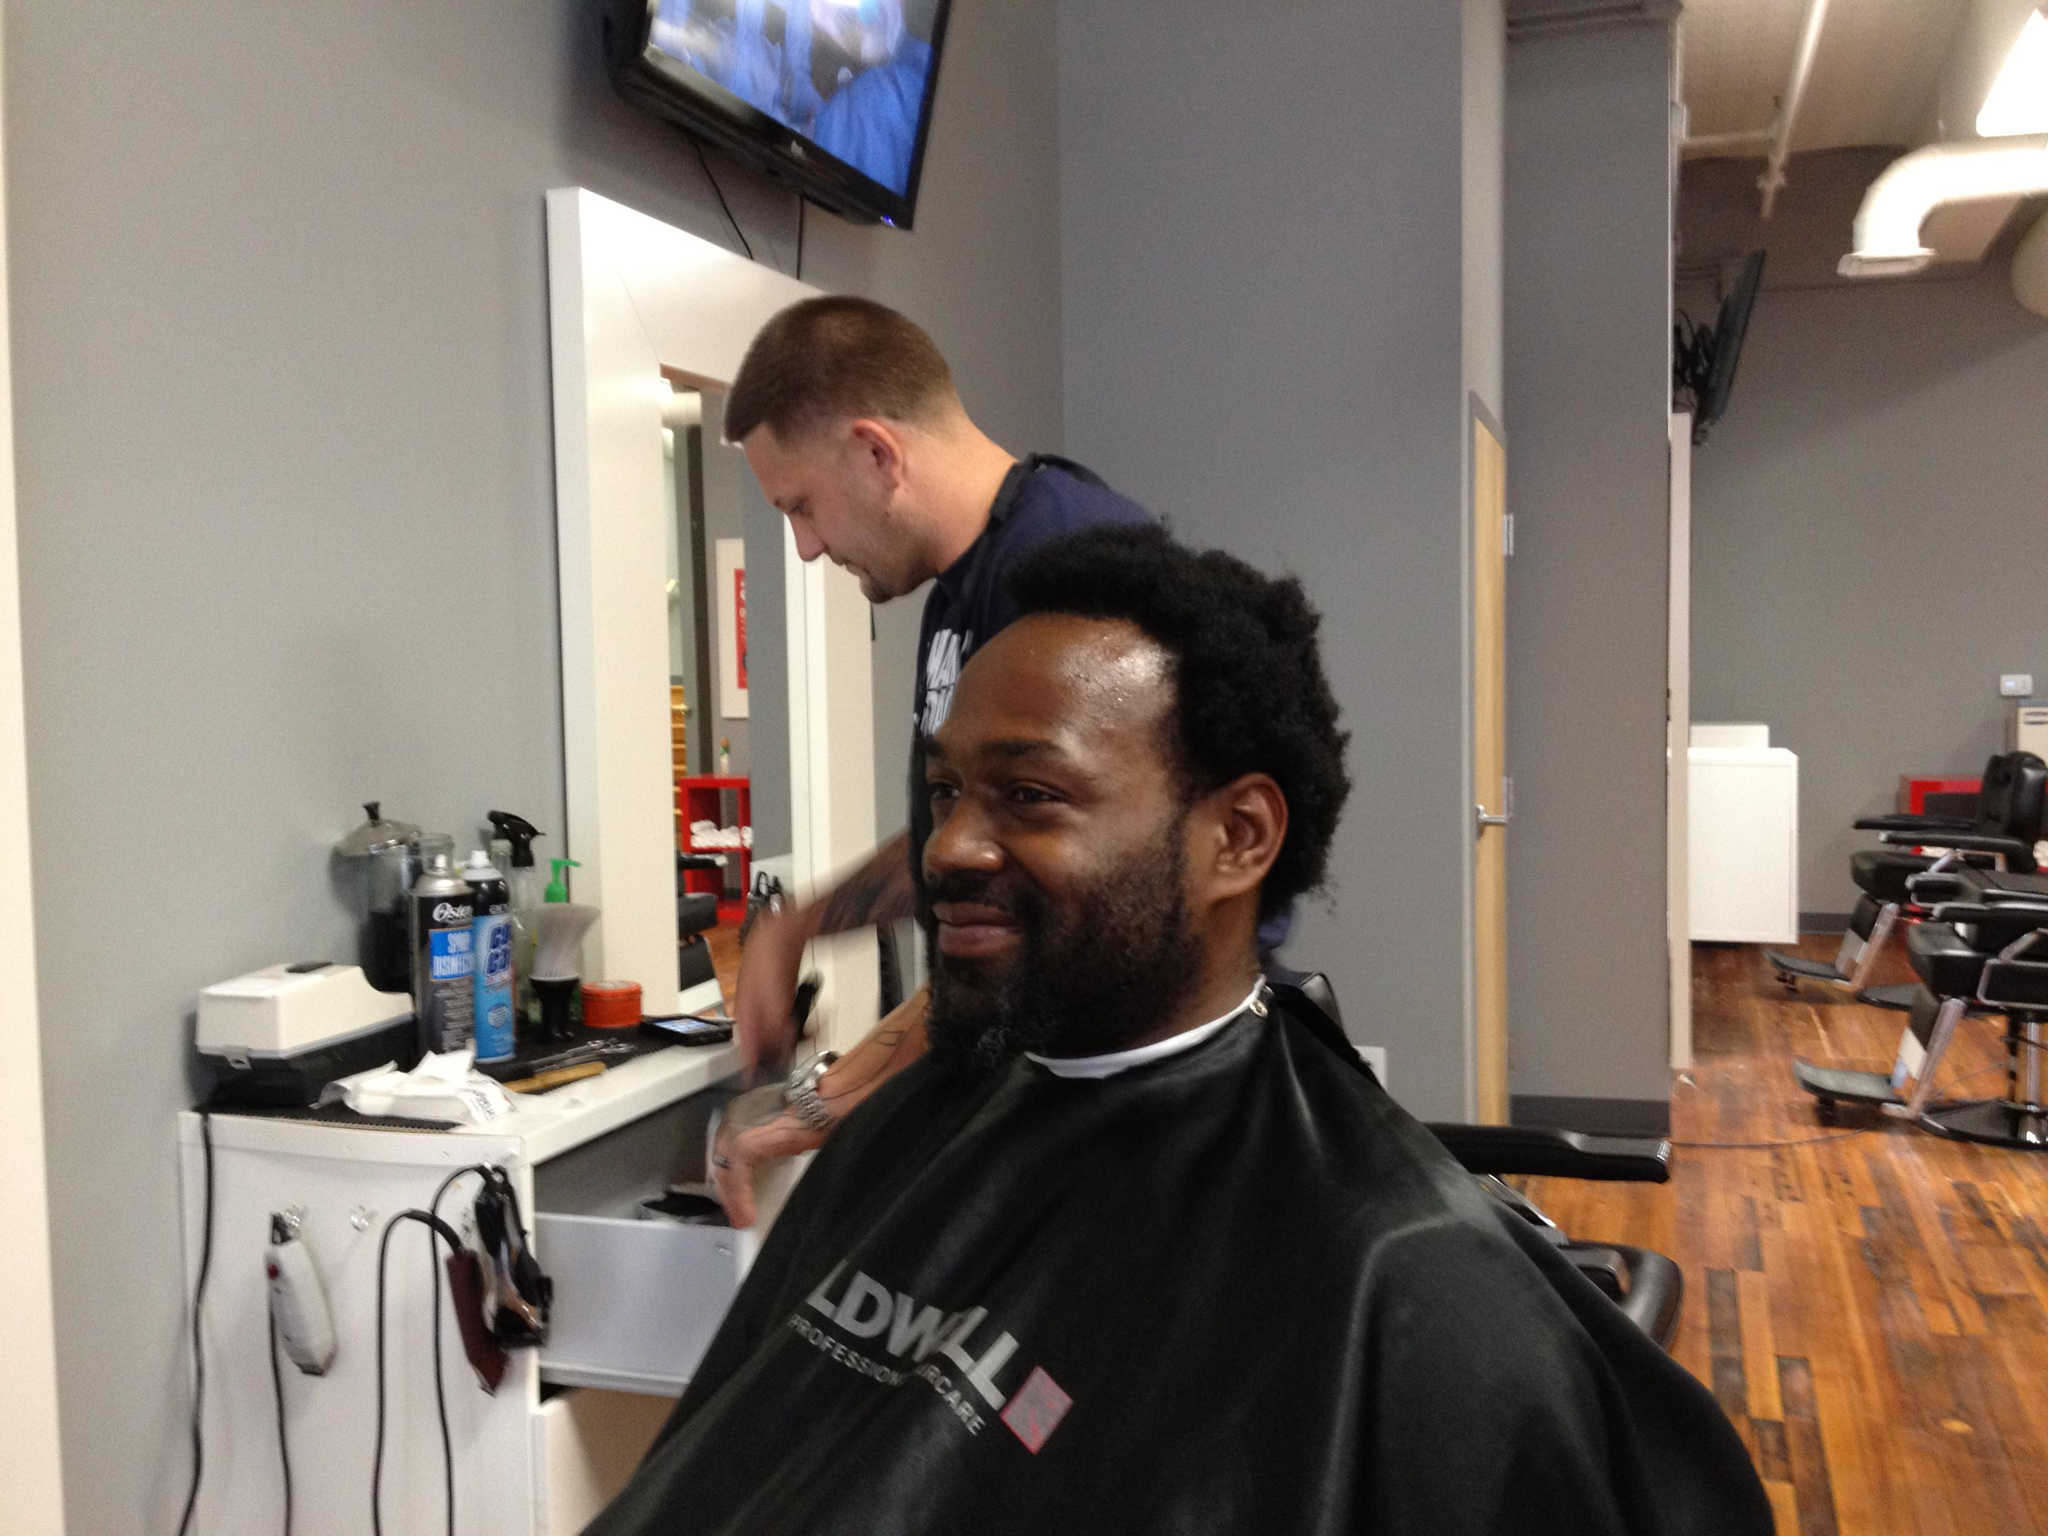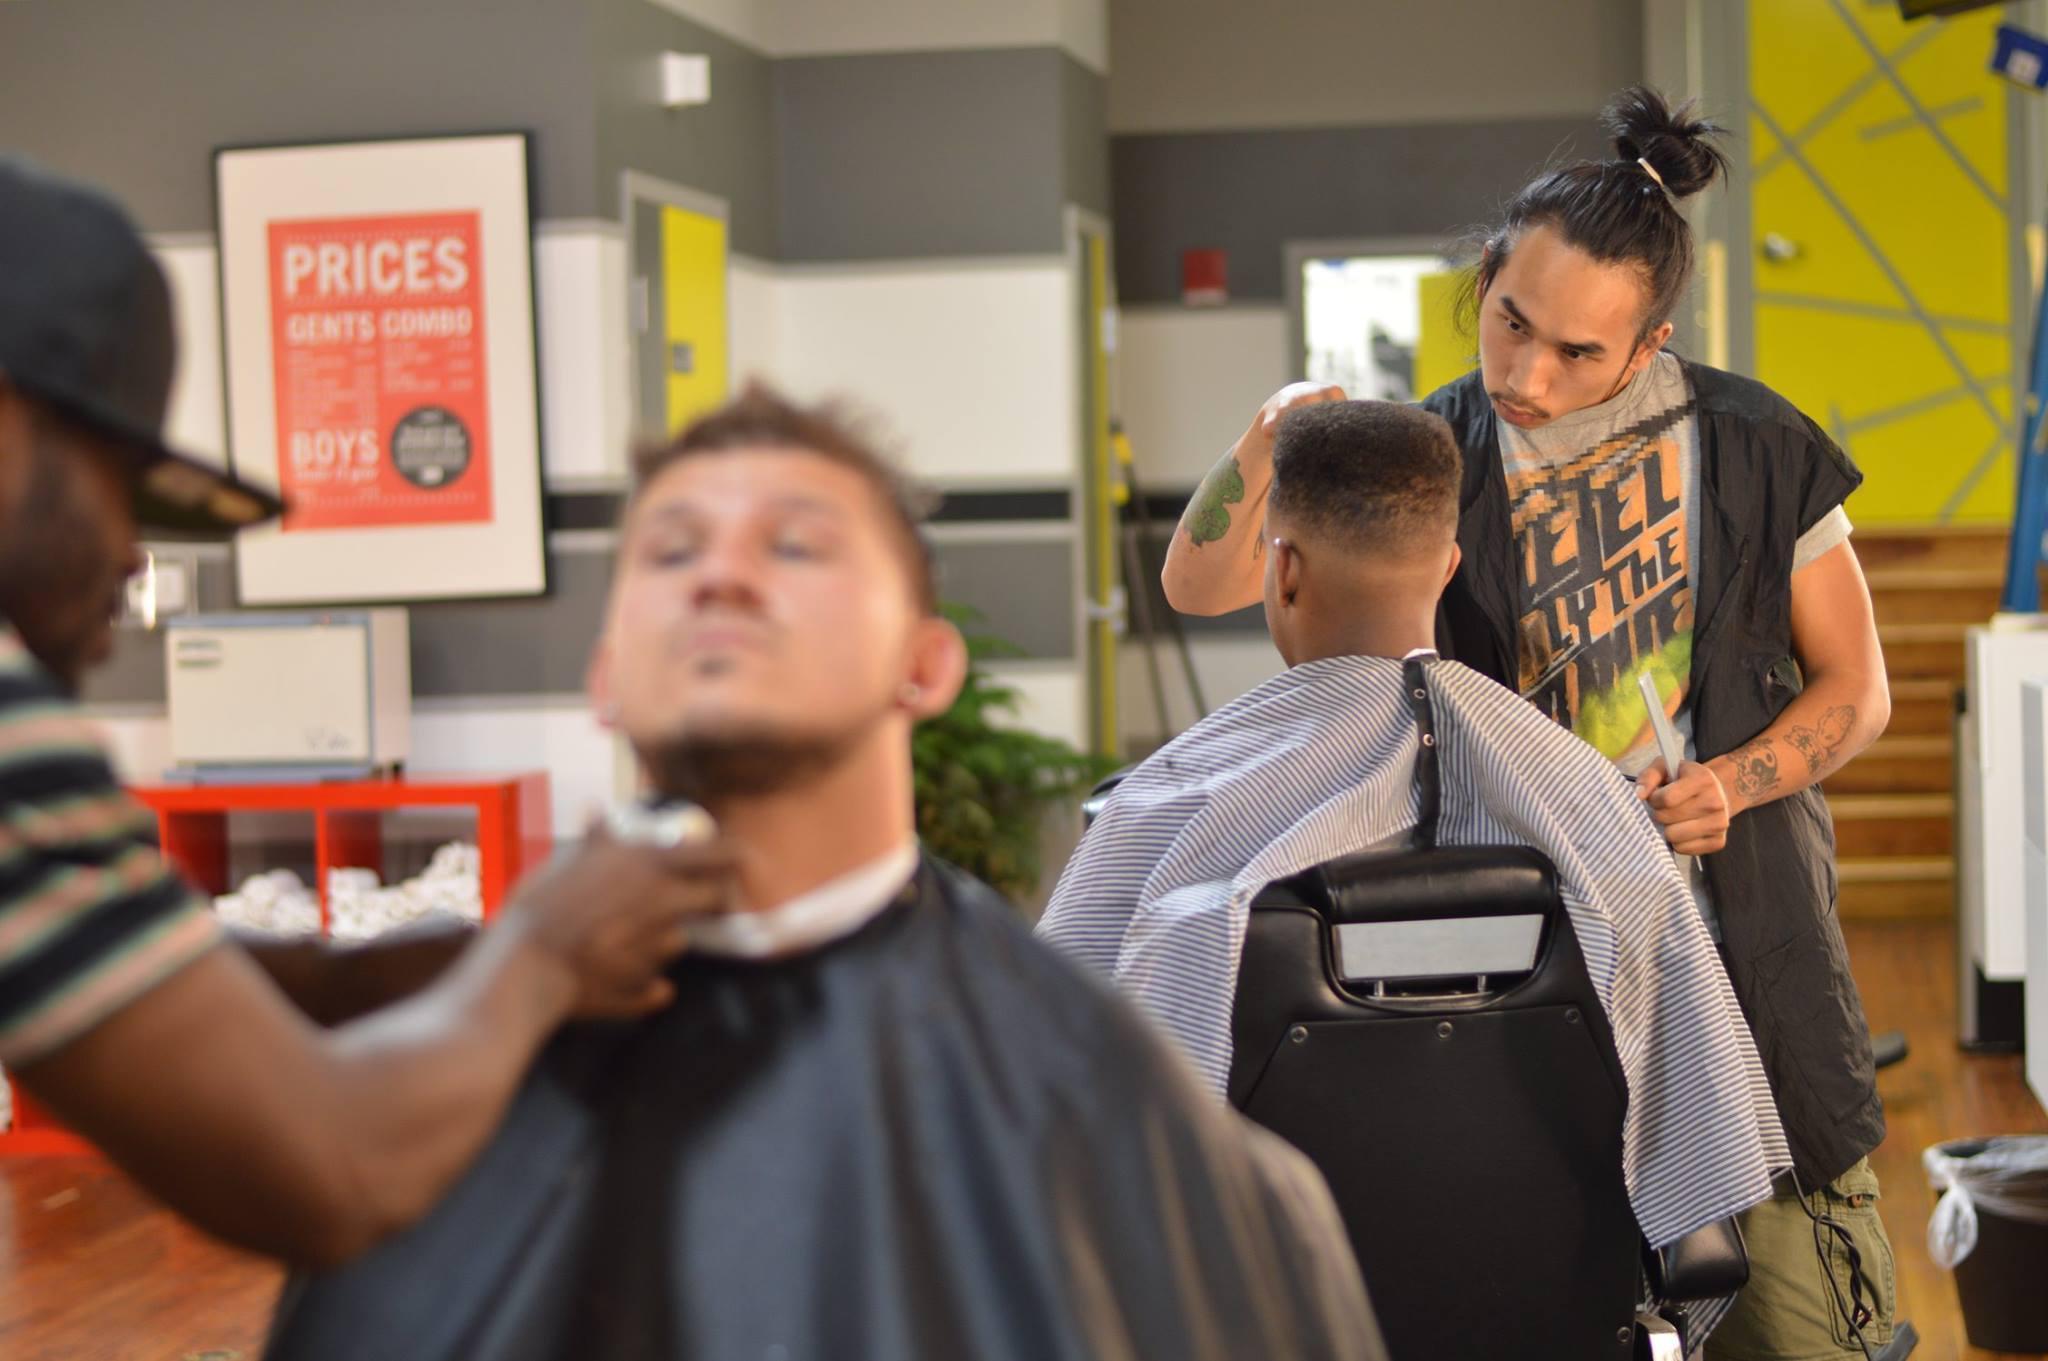The first image is the image on the left, the second image is the image on the right. For the images shown, is this caption "There are exactly four people." true? Answer yes or no. No. The first image is the image on the left, the second image is the image on the right. Given the left and right images, does the statement "There are three barbers in total." hold true? Answer yes or no. Yes. 